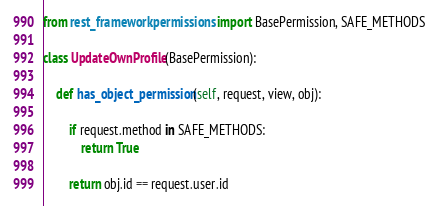Convert code to text. <code><loc_0><loc_0><loc_500><loc_500><_Python_>from rest_framework.permissions import BasePermission, SAFE_METHODS

class UpdateOwnProfile(BasePermission):

    def has_object_permission(self, request, view, obj):

        if request.method in SAFE_METHODS:
            return True

        return obj.id == request.user.id</code> 